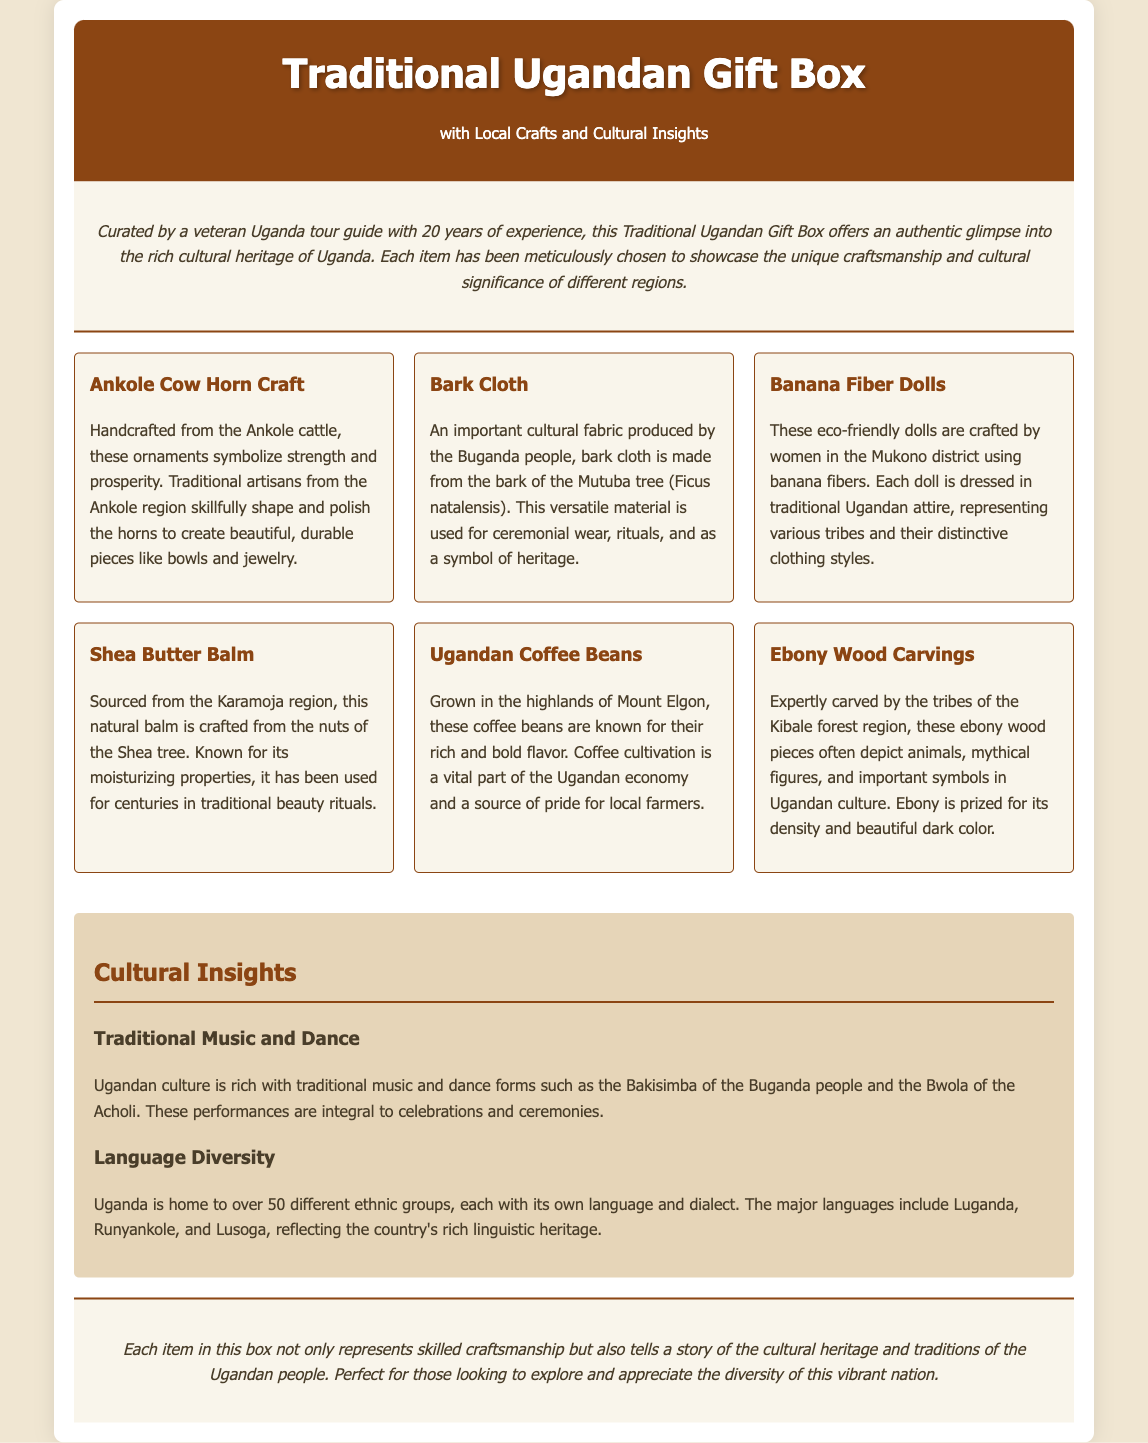What is the title of the product? The title of the product is displayed at the top of the document in a prominent header.
Answer: Traditional Ugandan Gift Box Who curated the gift box? The document states that the gift box was curated by an experienced individual in the field.
Answer: a veteran Uganda tour guide What is the main material used for bark cloth? The document specifically mentions the source of bark cloth as that part of a certain tree.
Answer: Mutuba tree How many different ethnic groups are mentioned in relation to language? The document explicitly notes the diversity of ethnic groups within Uganda.
Answer: over 50 What is included in the gift box that symbolizes strength? The document describes a specific craft which embodies this characteristic.
Answer: Ankole Cow Horn Craft Which region provides Shea Butter Balm? The document names the region where Shea butter is sourced from.
Answer: Karamoja What traditional craft is made from banana fibers? The document refers to a specific item crafted using this natural resource.
Answer: Banana Fiber Dolls What type of musical form is integral to Ugandan culture? The document highlights specific cultural practices linked to music.
Answer: Bakisimba What is a primary source of pride for local farmers mentioned in the document? The document refers to a product that significantly contributes to the local economy.
Answer: Ugandan Coffee Beans 